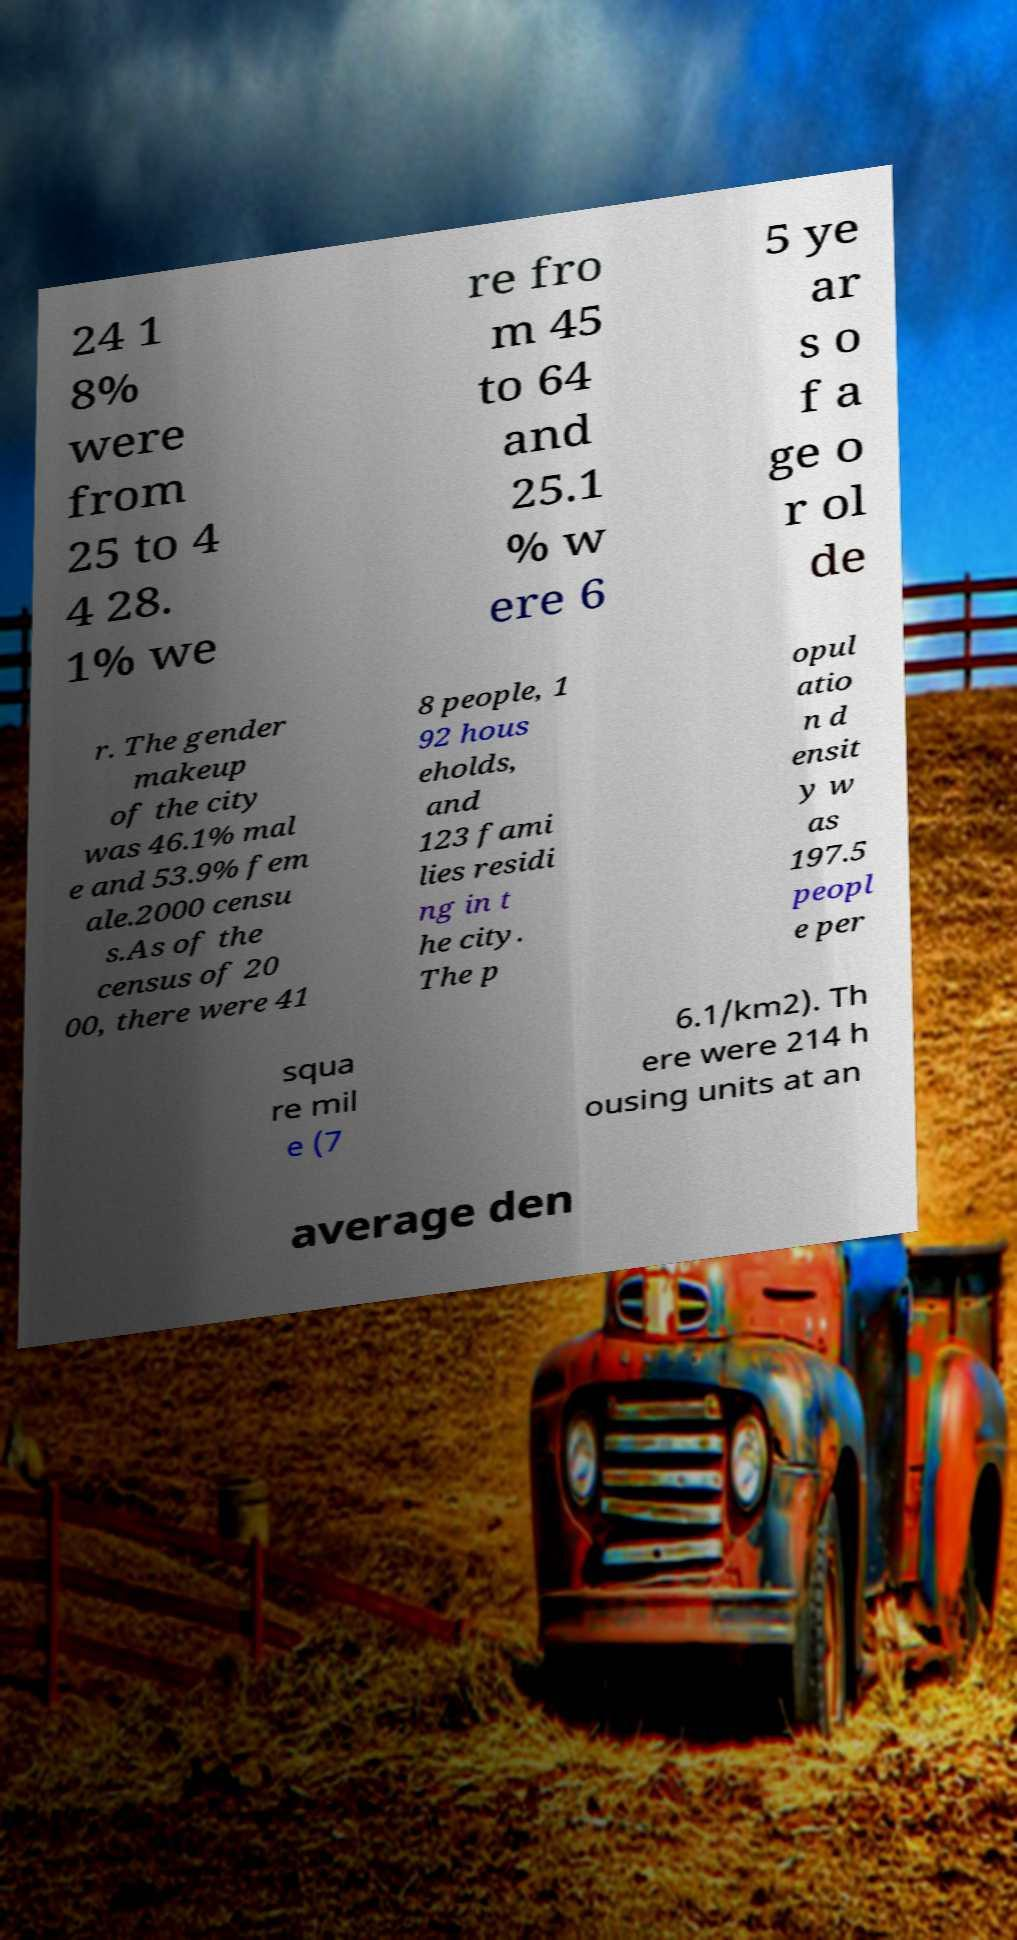For documentation purposes, I need the text within this image transcribed. Could you provide that? 24 1 8% were from 25 to 4 4 28. 1% we re fro m 45 to 64 and 25.1 % w ere 6 5 ye ar s o f a ge o r ol de r. The gender makeup of the city was 46.1% mal e and 53.9% fem ale.2000 censu s.As of the census of 20 00, there were 41 8 people, 1 92 hous eholds, and 123 fami lies residi ng in t he city. The p opul atio n d ensit y w as 197.5 peopl e per squa re mil e (7 6.1/km2). Th ere were 214 h ousing units at an average den 